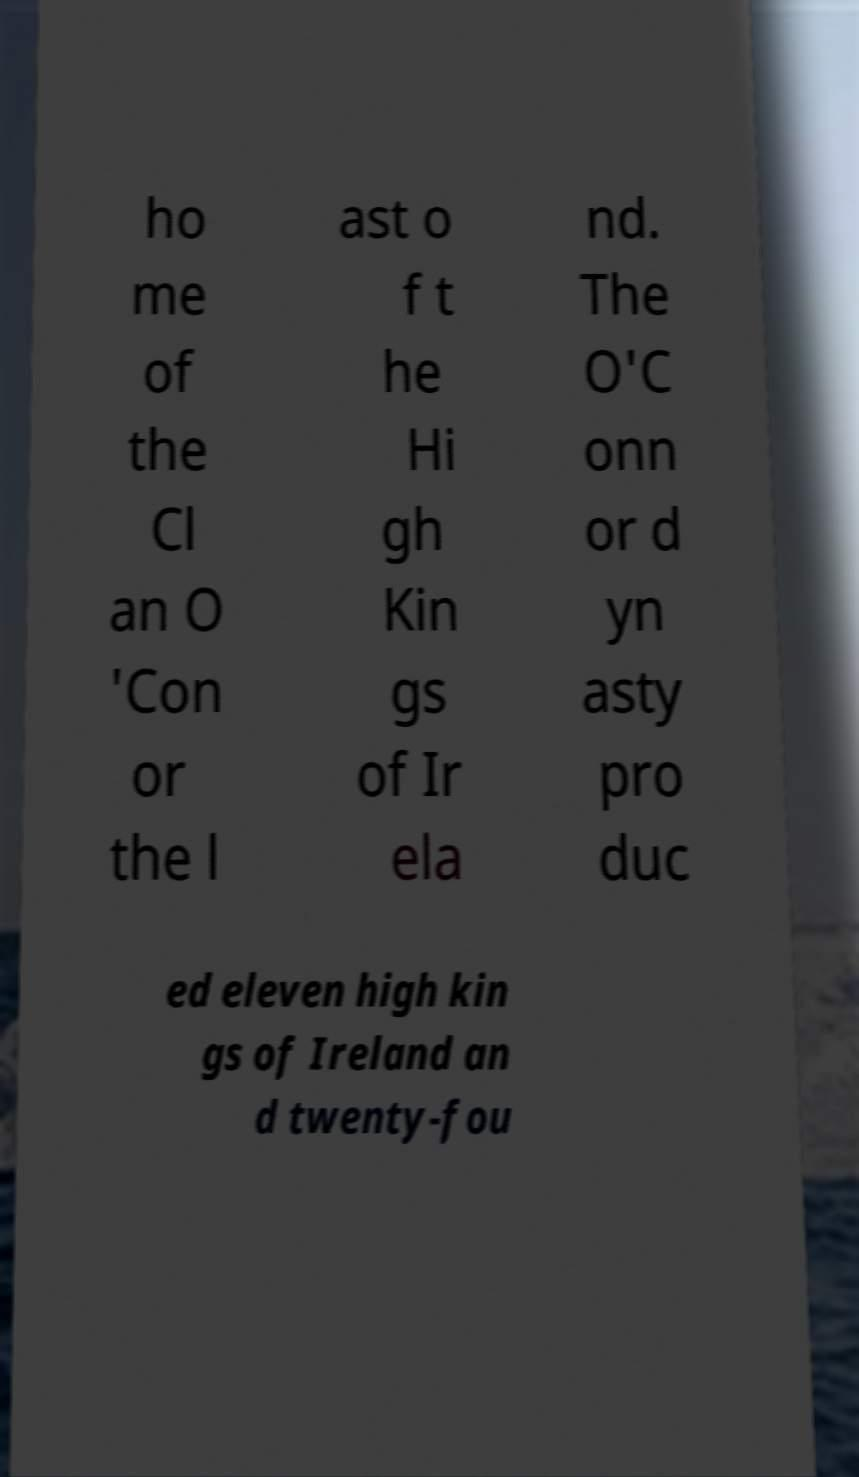Can you accurately transcribe the text from the provided image for me? ho me of the Cl an O 'Con or the l ast o f t he Hi gh Kin gs of Ir ela nd. The O'C onn or d yn asty pro duc ed eleven high kin gs of Ireland an d twenty-fou 